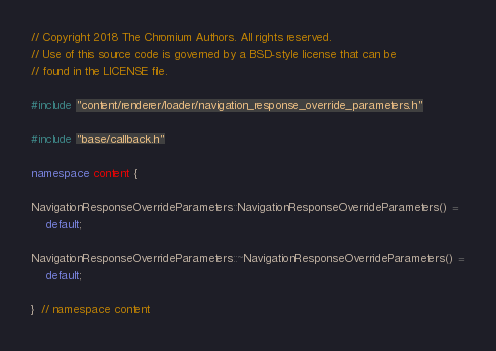Convert code to text. <code><loc_0><loc_0><loc_500><loc_500><_C++_>// Copyright 2018 The Chromium Authors. All rights reserved.
// Use of this source code is governed by a BSD-style license that can be
// found in the LICENSE file.

#include "content/renderer/loader/navigation_response_override_parameters.h"

#include "base/callback.h"

namespace content {

NavigationResponseOverrideParameters::NavigationResponseOverrideParameters() =
    default;

NavigationResponseOverrideParameters::~NavigationResponseOverrideParameters() =
    default;

}  // namespace content
</code> 